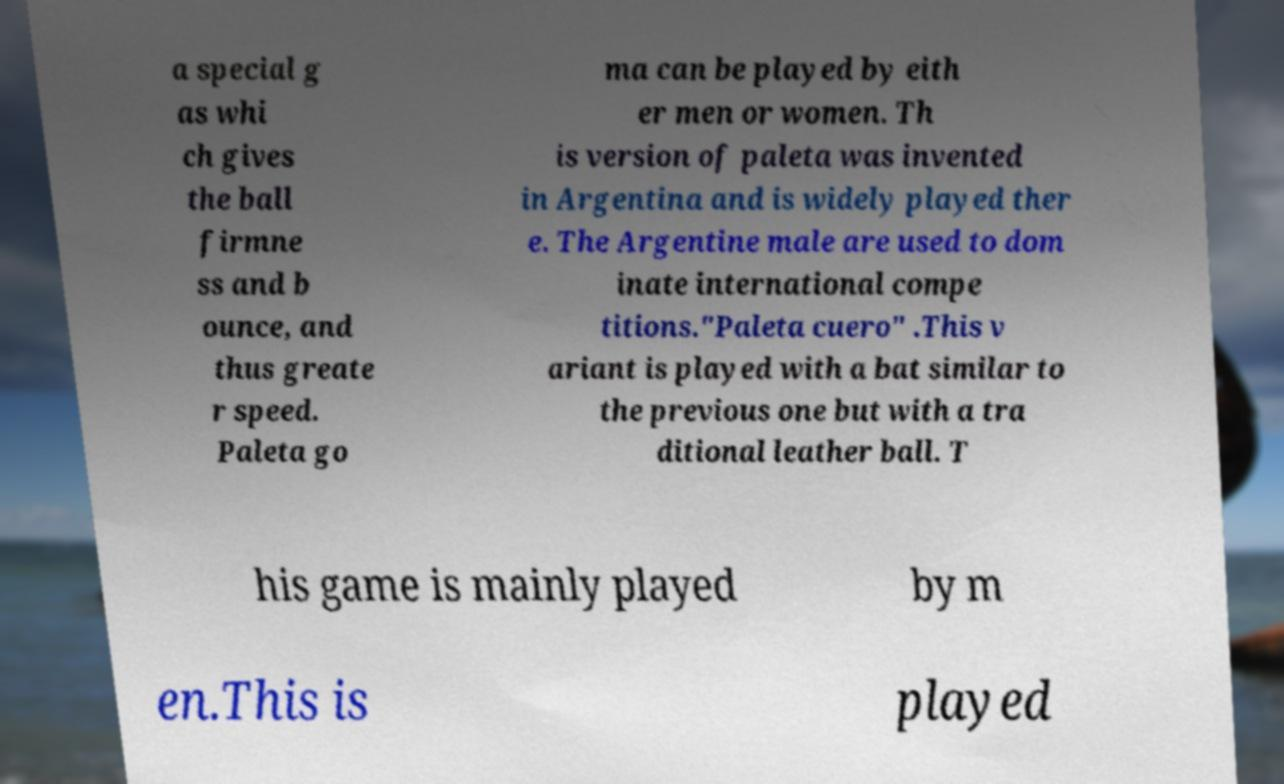Please read and relay the text visible in this image. What does it say? a special g as whi ch gives the ball firmne ss and b ounce, and thus greate r speed. Paleta go ma can be played by eith er men or women. Th is version of paleta was invented in Argentina and is widely played ther e. The Argentine male are used to dom inate international compe titions."Paleta cuero" .This v ariant is played with a bat similar to the previous one but with a tra ditional leather ball. T his game is mainly played by m en.This is played 